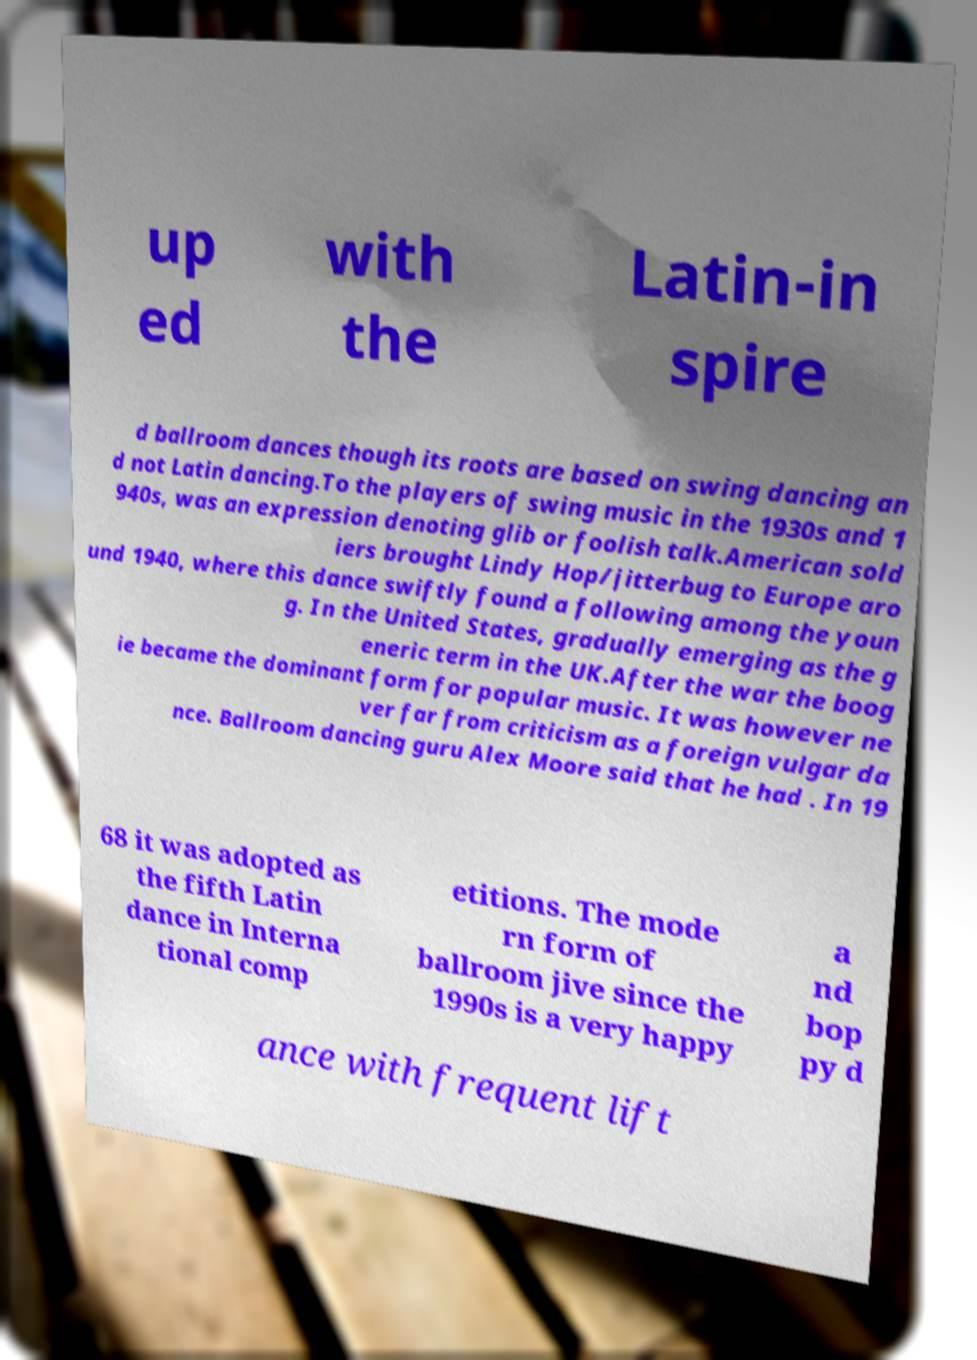Could you extract and type out the text from this image? up ed with the Latin-in spire d ballroom dances though its roots are based on swing dancing an d not Latin dancing.To the players of swing music in the 1930s and 1 940s, was an expression denoting glib or foolish talk.American sold iers brought Lindy Hop/jitterbug to Europe aro und 1940, where this dance swiftly found a following among the youn g. In the United States, gradually emerging as the g eneric term in the UK.After the war the boog ie became the dominant form for popular music. It was however ne ver far from criticism as a foreign vulgar da nce. Ballroom dancing guru Alex Moore said that he had . In 19 68 it was adopted as the fifth Latin dance in Interna tional comp etitions. The mode rn form of ballroom jive since the 1990s is a very happy a nd bop py d ance with frequent lift 